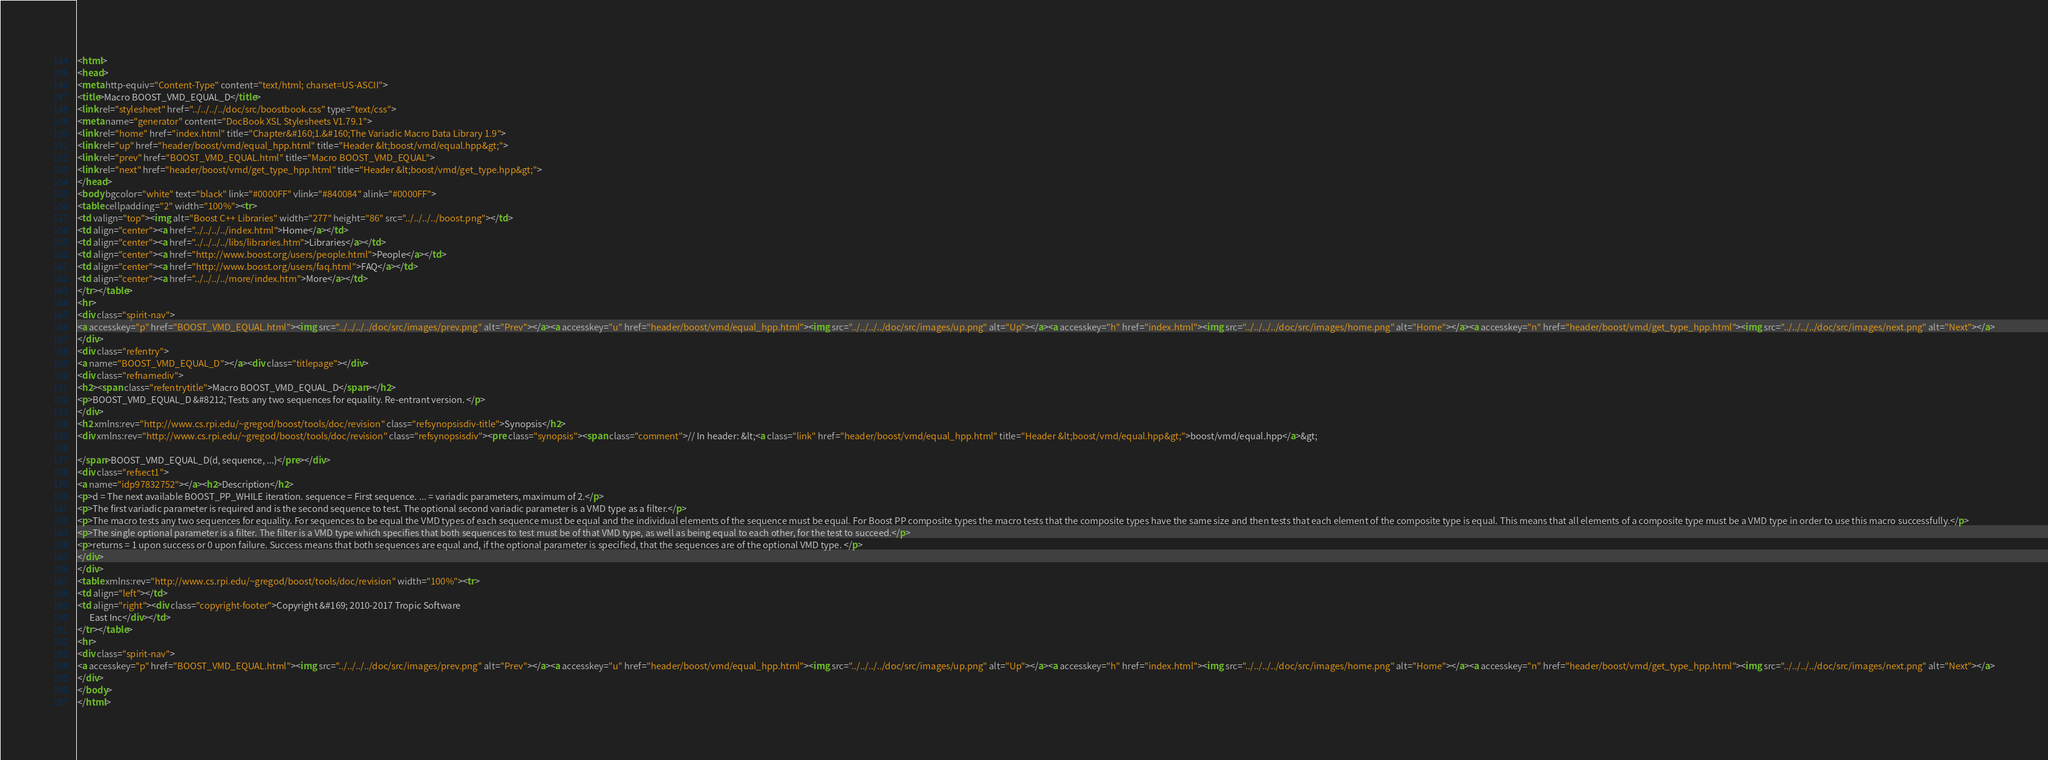Convert code to text. <code><loc_0><loc_0><loc_500><loc_500><_HTML_><html>
<head>
<meta http-equiv="Content-Type" content="text/html; charset=US-ASCII">
<title>Macro BOOST_VMD_EQUAL_D</title>
<link rel="stylesheet" href="../../../../doc/src/boostbook.css" type="text/css">
<meta name="generator" content="DocBook XSL Stylesheets V1.79.1">
<link rel="home" href="index.html" title="Chapter&#160;1.&#160;The Variadic Macro Data Library 1.9">
<link rel="up" href="header/boost/vmd/equal_hpp.html" title="Header &lt;boost/vmd/equal.hpp&gt;">
<link rel="prev" href="BOOST_VMD_EQUAL.html" title="Macro BOOST_VMD_EQUAL">
<link rel="next" href="header/boost/vmd/get_type_hpp.html" title="Header &lt;boost/vmd/get_type.hpp&gt;">
</head>
<body bgcolor="white" text="black" link="#0000FF" vlink="#840084" alink="#0000FF">
<table cellpadding="2" width="100%"><tr>
<td valign="top"><img alt="Boost C++ Libraries" width="277" height="86" src="../../../../boost.png"></td>
<td align="center"><a href="../../../../index.html">Home</a></td>
<td align="center"><a href="../../../../libs/libraries.htm">Libraries</a></td>
<td align="center"><a href="http://www.boost.org/users/people.html">People</a></td>
<td align="center"><a href="http://www.boost.org/users/faq.html">FAQ</a></td>
<td align="center"><a href="../../../../more/index.htm">More</a></td>
</tr></table>
<hr>
<div class="spirit-nav">
<a accesskey="p" href="BOOST_VMD_EQUAL.html"><img src="../../../../doc/src/images/prev.png" alt="Prev"></a><a accesskey="u" href="header/boost/vmd/equal_hpp.html"><img src="../../../../doc/src/images/up.png" alt="Up"></a><a accesskey="h" href="index.html"><img src="../../../../doc/src/images/home.png" alt="Home"></a><a accesskey="n" href="header/boost/vmd/get_type_hpp.html"><img src="../../../../doc/src/images/next.png" alt="Next"></a>
</div>
<div class="refentry">
<a name="BOOST_VMD_EQUAL_D"></a><div class="titlepage"></div>
<div class="refnamediv">
<h2><span class="refentrytitle">Macro BOOST_VMD_EQUAL_D</span></h2>
<p>BOOST_VMD_EQUAL_D &#8212; Tests any two sequences for equality. Re-entrant version. </p>
</div>
<h2 xmlns:rev="http://www.cs.rpi.edu/~gregod/boost/tools/doc/revision" class="refsynopsisdiv-title">Synopsis</h2>
<div xmlns:rev="http://www.cs.rpi.edu/~gregod/boost/tools/doc/revision" class="refsynopsisdiv"><pre class="synopsis"><span class="comment">// In header: &lt;<a class="link" href="header/boost/vmd/equal_hpp.html" title="Header &lt;boost/vmd/equal.hpp&gt;">boost/vmd/equal.hpp</a>&gt;

</span>BOOST_VMD_EQUAL_D(d, sequence, ...)</pre></div>
<div class="refsect1">
<a name="idp97832752"></a><h2>Description</h2>
<p>d = The next available BOOST_PP_WHILE iteration. sequence = First sequence. ... = variadic parameters, maximum of 2.</p>
<p>The first variadic parameter is required and is the second sequence to test. The optional second variadic parameter is a VMD type as a filter.</p>
<p>The macro tests any two sequences for equality. For sequences to be equal the VMD types of each sequence must be equal and the individual elements of the sequence must be equal. For Boost PP composite types the macro tests that the composite types have the same size and then tests that each element of the composite type is equal. This means that all elements of a composite type must be a VMD type in order to use this macro successfully.</p>
<p>The single optional parameter is a filter. The filter is a VMD type which specifies that both sequences to test must be of that VMD type, as well as being equal to each other, for the test to succeed.</p>
<p>returns = 1 upon success or 0 upon failure. Success means that both sequences are equal and, if the optional parameter is specified, that the sequences are of the optional VMD type. </p>
</div>
</div>
<table xmlns:rev="http://www.cs.rpi.edu/~gregod/boost/tools/doc/revision" width="100%"><tr>
<td align="left"></td>
<td align="right"><div class="copyright-footer">Copyright &#169; 2010-2017 Tropic Software
      East Inc</div></td>
</tr></table>
<hr>
<div class="spirit-nav">
<a accesskey="p" href="BOOST_VMD_EQUAL.html"><img src="../../../../doc/src/images/prev.png" alt="Prev"></a><a accesskey="u" href="header/boost/vmd/equal_hpp.html"><img src="../../../../doc/src/images/up.png" alt="Up"></a><a accesskey="h" href="index.html"><img src="../../../../doc/src/images/home.png" alt="Home"></a><a accesskey="n" href="header/boost/vmd/get_type_hpp.html"><img src="../../../../doc/src/images/next.png" alt="Next"></a>
</div>
</body>
</html>
</code> 